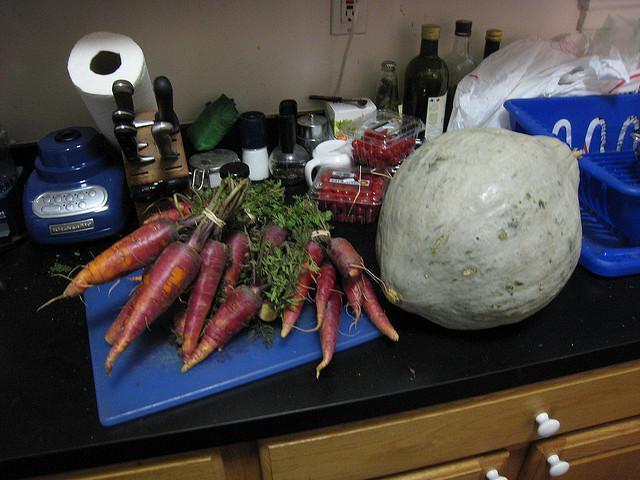Which food is rich in vitamin A?
Answer the question by selecting the correct answer among the 4 following choices.
Options: Cilantro, melon, carrot, tomato. Carrot. 